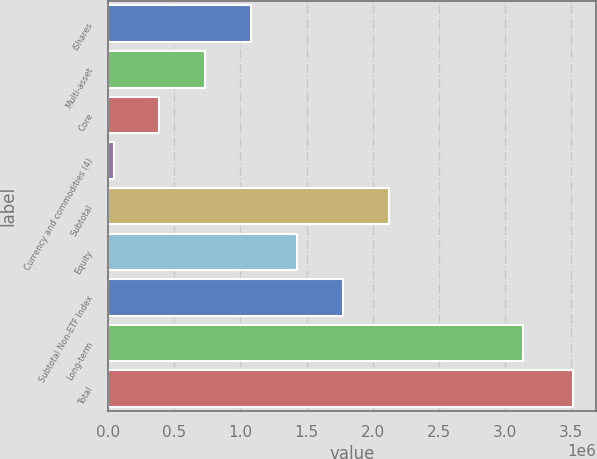Convert chart. <chart><loc_0><loc_0><loc_500><loc_500><bar_chart><fcel>iShares<fcel>Multi-asset<fcel>Core<fcel>Currency and commodities (4)<fcel>Subtotal<fcel>Equity<fcel>Subtotal Non-ETF Index<fcel>Long-term<fcel>Total<nl><fcel>1.08272e+06<fcel>735577<fcel>388439<fcel>41301<fcel>2.12413e+06<fcel>1.42985e+06<fcel>1.77699e+06<fcel>3.13795e+06<fcel>3.51268e+06<nl></chart> 